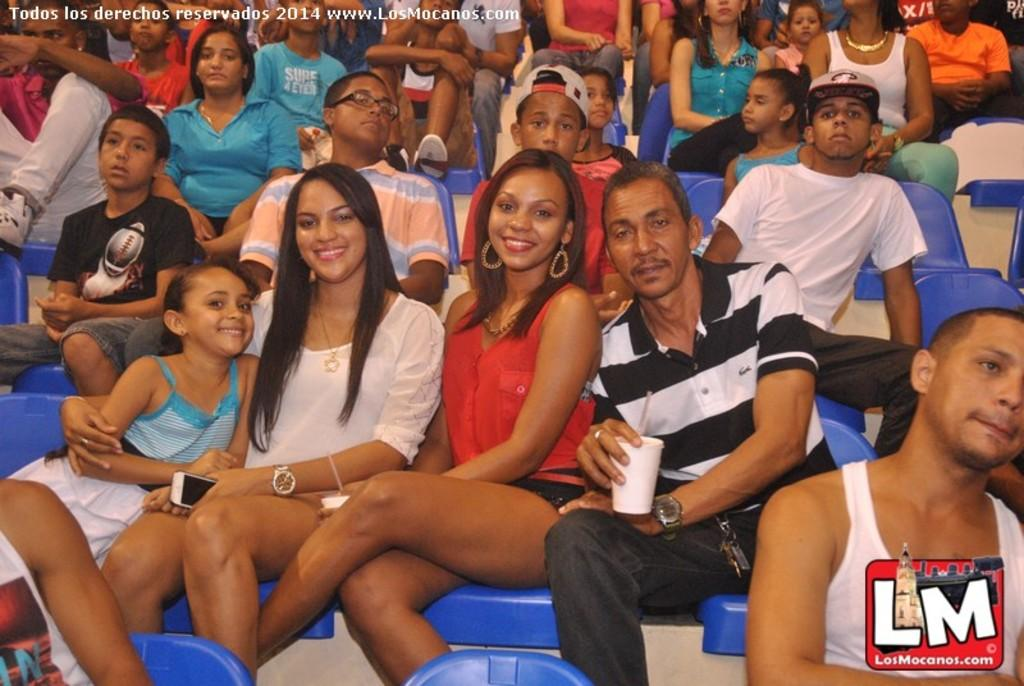How many people are in the image? There are persons in the image, but the exact number is not specified. What are the persons doing in the image? The persons are seated on chairs in the image. What type of stamp can be seen on the grass in the image? There is no stamp or grass present in the image; it only shows persons seated on chairs. 